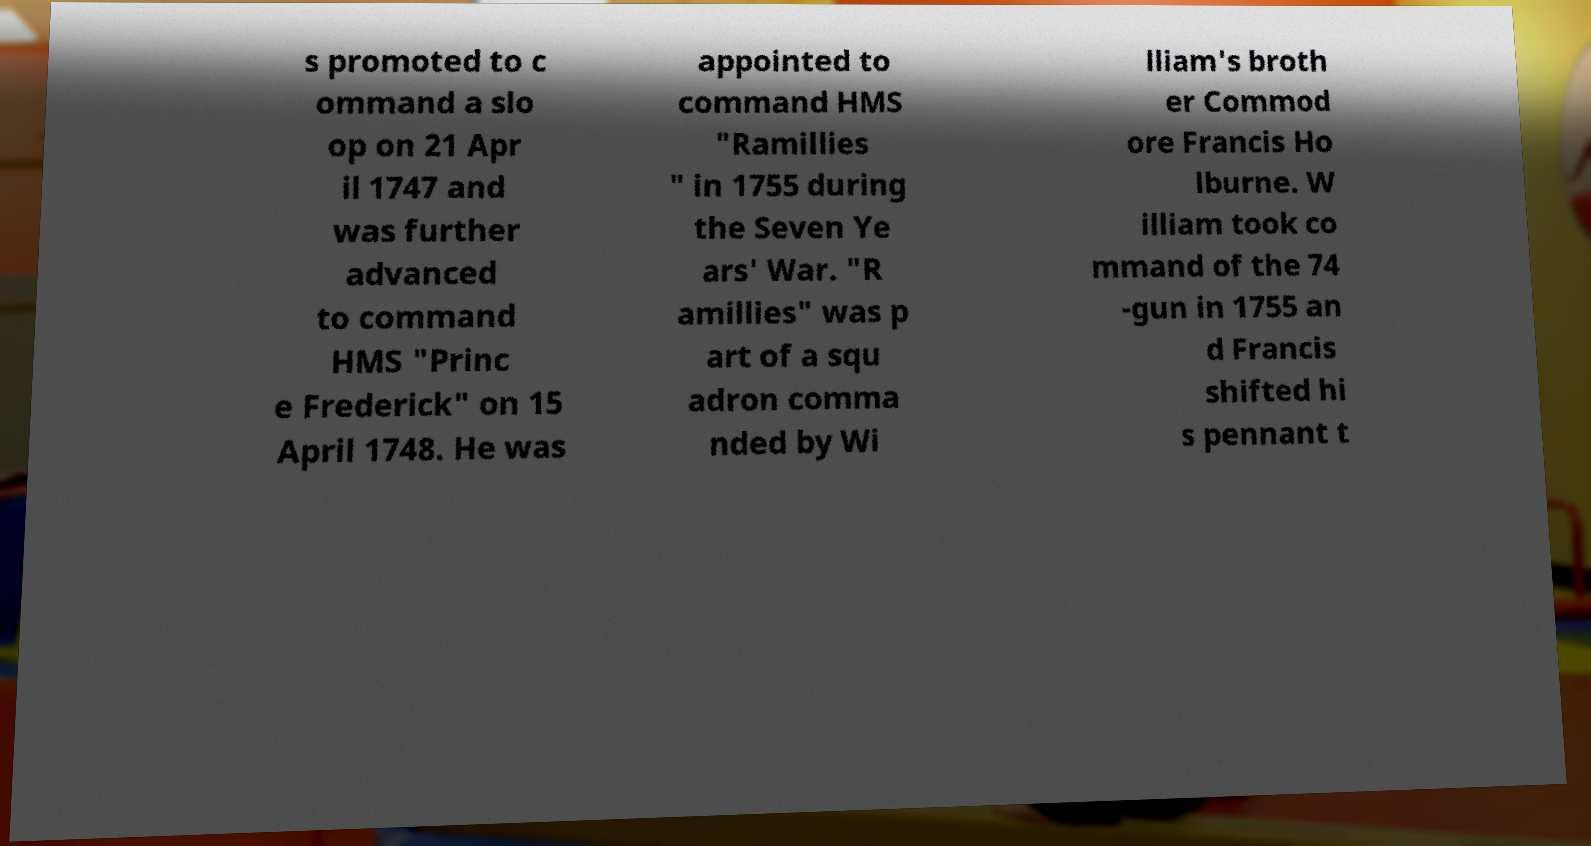Could you extract and type out the text from this image? s promoted to c ommand a slo op on 21 Apr il 1747 and was further advanced to command HMS "Princ e Frederick" on 15 April 1748. He was appointed to command HMS "Ramillies " in 1755 during the Seven Ye ars' War. "R amillies" was p art of a squ adron comma nded by Wi lliam's broth er Commod ore Francis Ho lburne. W illiam took co mmand of the 74 -gun in 1755 an d Francis shifted hi s pennant t 